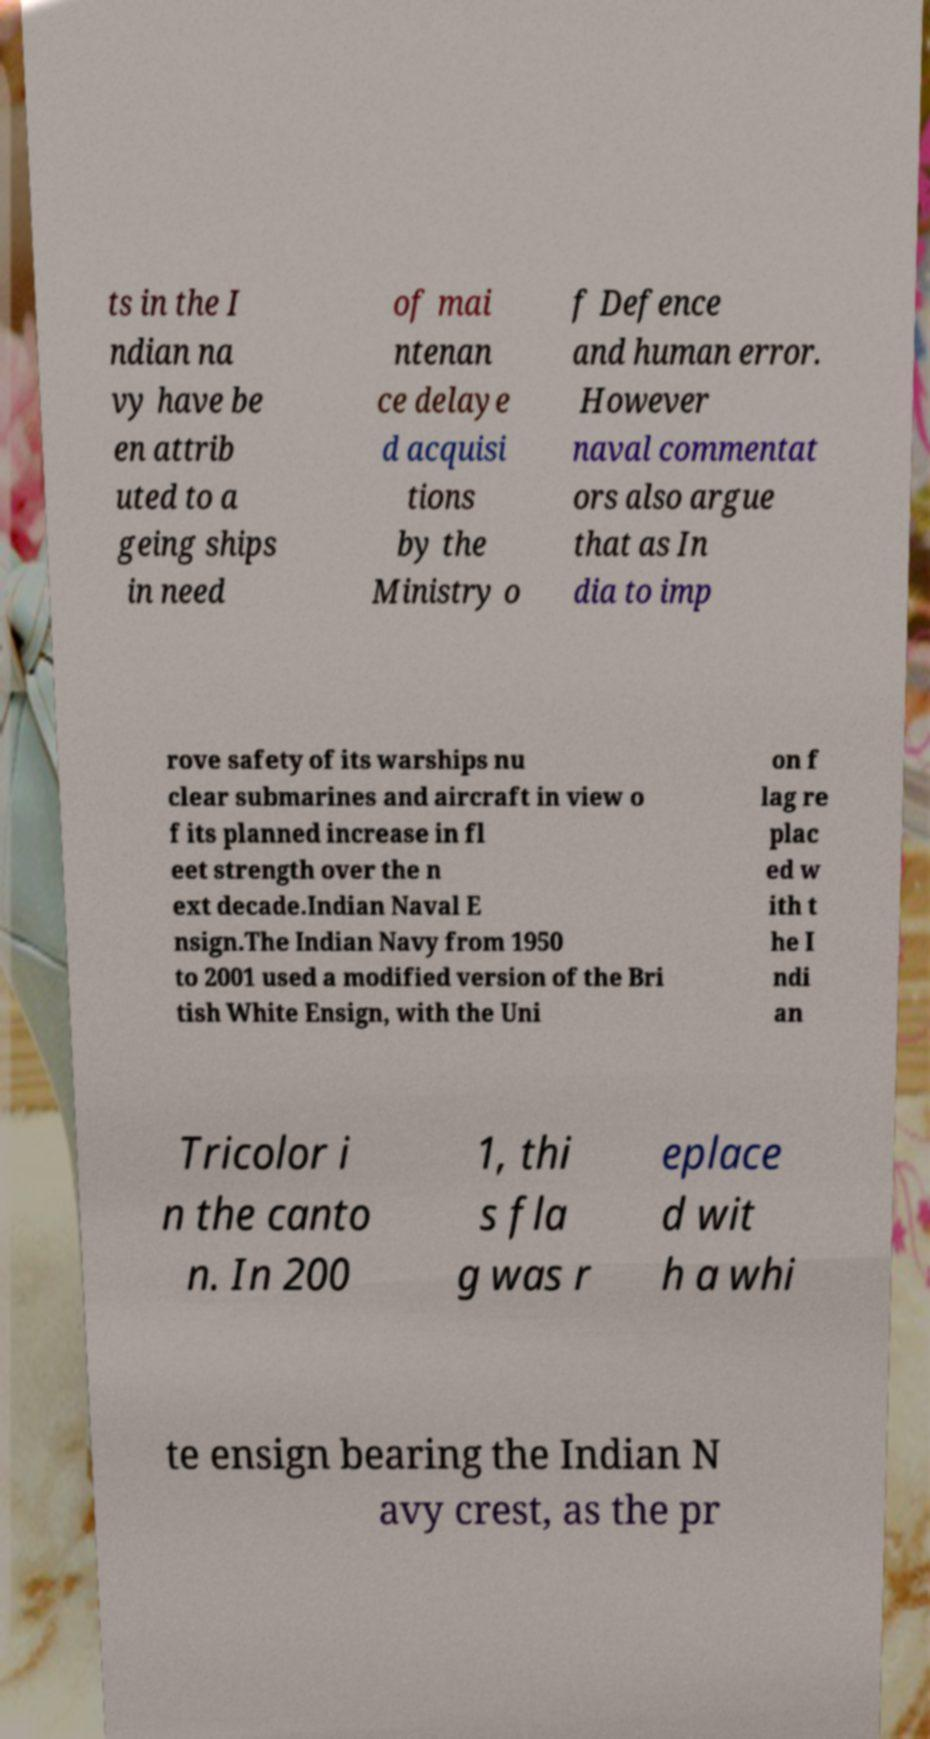Please read and relay the text visible in this image. What does it say? ts in the I ndian na vy have be en attrib uted to a geing ships in need of mai ntenan ce delaye d acquisi tions by the Ministry o f Defence and human error. However naval commentat ors also argue that as In dia to imp rove safety of its warships nu clear submarines and aircraft in view o f its planned increase in fl eet strength over the n ext decade.Indian Naval E nsign.The Indian Navy from 1950 to 2001 used a modified version of the Bri tish White Ensign, with the Uni on f lag re plac ed w ith t he I ndi an Tricolor i n the canto n. In 200 1, thi s fla g was r eplace d wit h a whi te ensign bearing the Indian N avy crest, as the pr 